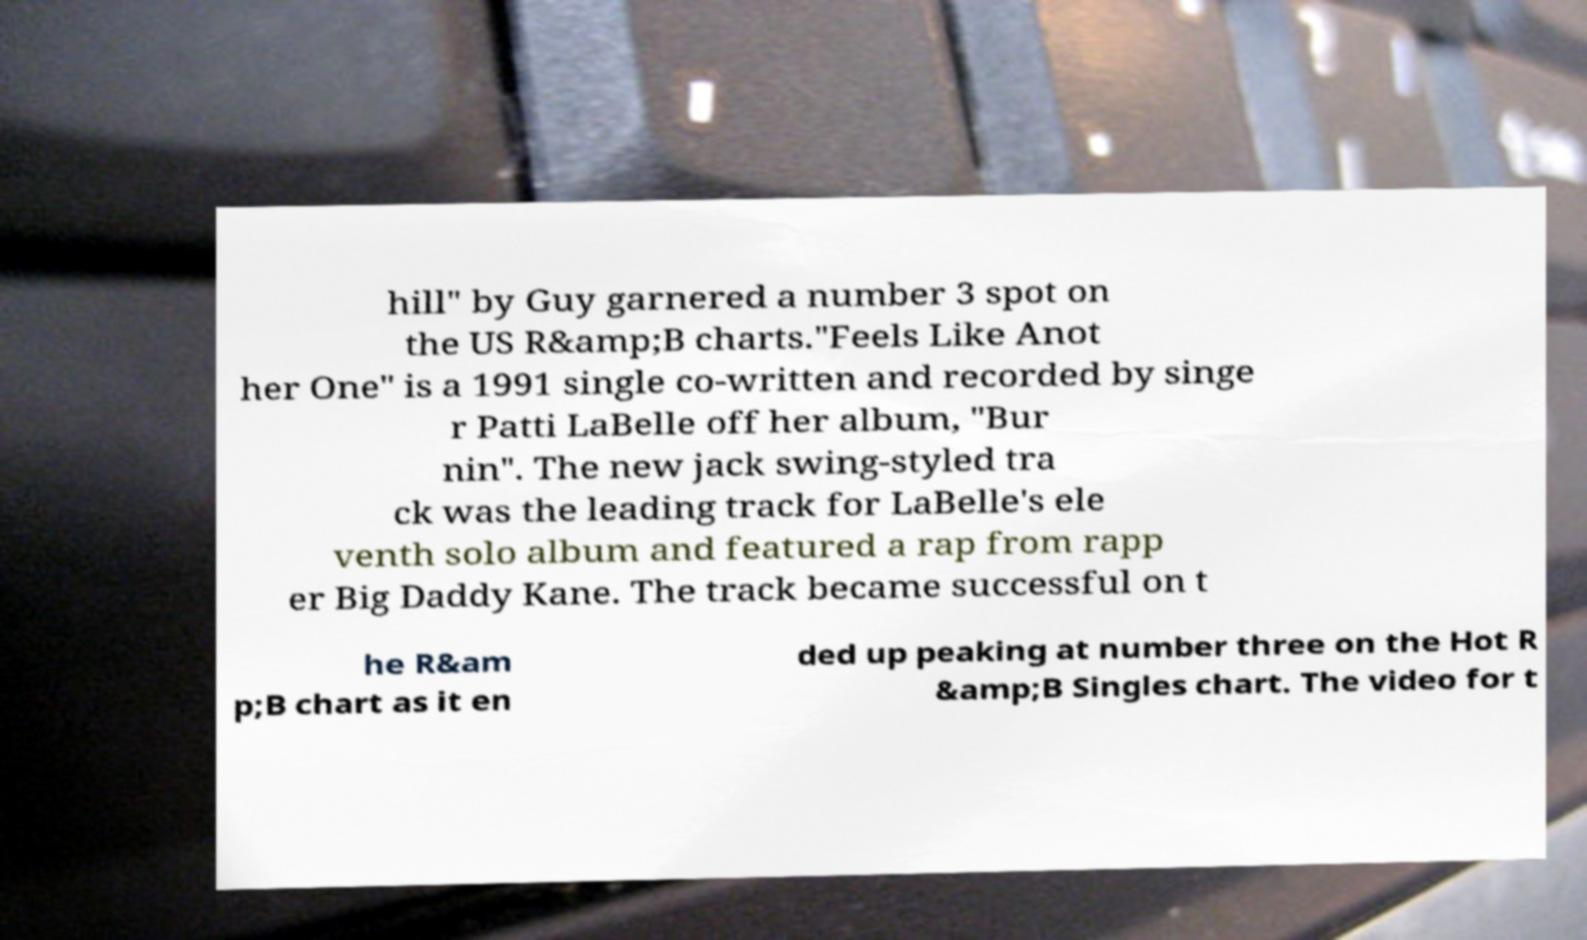Can you accurately transcribe the text from the provided image for me? hill" by Guy garnered a number 3 spot on the US R&amp;B charts."Feels Like Anot her One" is a 1991 single co-written and recorded by singe r Patti LaBelle off her album, "Bur nin". The new jack swing-styled tra ck was the leading track for LaBelle's ele venth solo album and featured a rap from rapp er Big Daddy Kane. The track became successful on t he R&am p;B chart as it en ded up peaking at number three on the Hot R &amp;B Singles chart. The video for t 